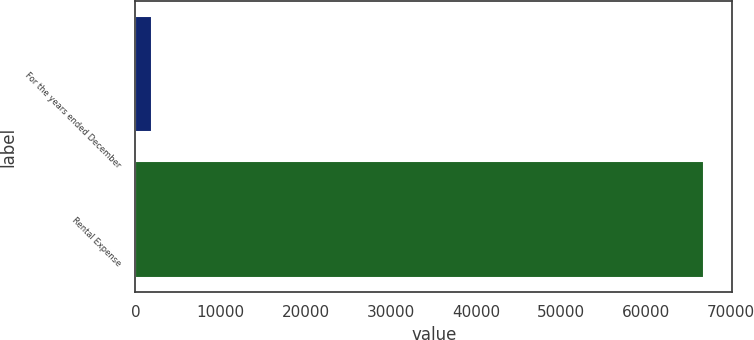<chart> <loc_0><loc_0><loc_500><loc_500><bar_chart><fcel>For the years ended December<fcel>Rental Expense<nl><fcel>2016<fcel>66774<nl></chart> 